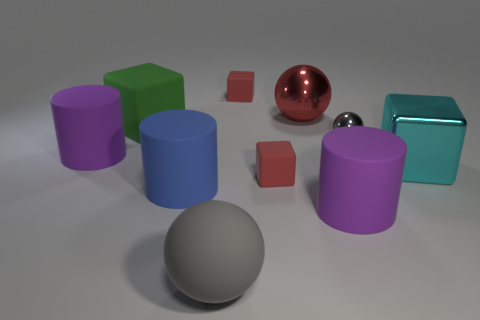Do the metal ball on the left side of the gray shiny object and the big shiny block have the same color?
Your response must be concise. No. Are there any other things that have the same shape as the tiny gray object?
Ensure brevity in your answer.  Yes. Are there any matte cubes in front of the big purple rubber cylinder that is behind the large blue rubber object?
Ensure brevity in your answer.  Yes. Is the number of blue matte objects right of the gray shiny sphere less than the number of small red matte objects that are in front of the big gray matte thing?
Provide a short and direct response. No. There is a block that is to the left of the gray object that is in front of the purple matte object that is on the right side of the red sphere; how big is it?
Your answer should be very brief. Large. There is a purple matte thing on the left side of the blue matte object; is it the same size as the gray matte thing?
Your response must be concise. Yes. How many other objects are the same material as the tiny sphere?
Offer a terse response. 2. Are there more cyan shiny blocks than small green balls?
Keep it short and to the point. Yes. There is a object behind the red sphere behind the red matte object in front of the big red shiny sphere; what is its material?
Provide a succinct answer. Rubber. Is the color of the big rubber ball the same as the tiny shiny object?
Offer a very short reply. Yes. 